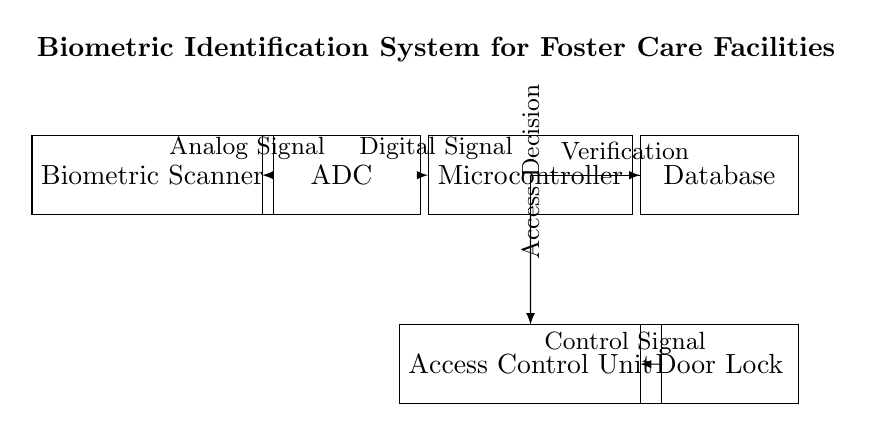What is the first component in the circuit? The first component, located at the leftmost position, is the Biometric Scanner.
Answer: Biometric Scanner What does the ADC stand for? ADC stands for Analog-to-Digital Converter, which is the component that converts analog signals from the biometric scanner to digital signals for processing.
Answer: Analog-to-Digital Converter How many connections are shown in the circuit? There are six arrows showing directed connections between the components in the circuit diagram.
Answer: Six What component receives verification signal from the microcontroller? The component that receives the verification signal from the microcontroller is the Access Control Unit, which is responsible for decision-making regarding access.
Answer: Access Control Unit Which component is responsible for locking the door? The component responsible for locking the door is the Door Lock, which is controlled by the access decisions made by the Access Control Unit.
Answer: Door Lock What type of signal does the Biometric Scanner output? The Biometric Scanner outputs an analog signal that is then converted to digital form by the ADC for further processing.
Answer: Analog Signal What is the purpose of the microcontroller in this circuit? The microcontroller processes the digital signal from the ADC, verifies the identity against the database, and makes access decisions that ultimately control the door lock.
Answer: Processing and Decision-Making 